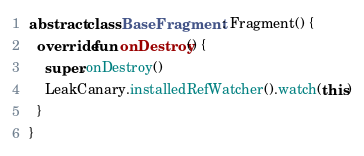<code> <loc_0><loc_0><loc_500><loc_500><_Kotlin_>
abstract class BaseFragment : Fragment() {
  override fun onDestroy() {
    super.onDestroy()
    LeakCanary.installedRefWatcher().watch(this)
  }
}
</code> 